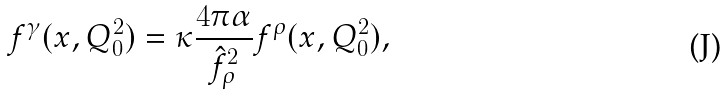<formula> <loc_0><loc_0><loc_500><loc_500>f ^ { \gamma } ( x , Q _ { 0 } ^ { 2 } ) = \kappa \frac { 4 \pi \alpha } { \hat { f } ^ { 2 } _ { \rho } } f ^ { \rho } ( x , Q _ { 0 } ^ { 2 } ) ,</formula> 